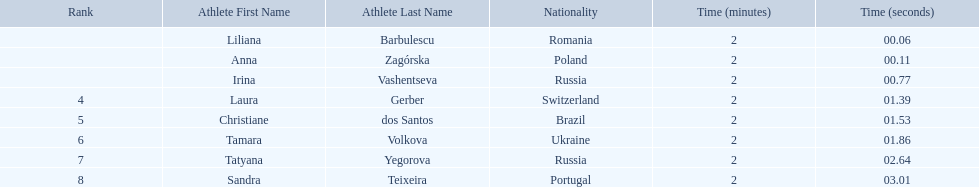What athletes are in the top five for the women's 800 metres? Liliana Barbulescu, Anna Zagórska, Irina Vashentseva, Laura Gerber, Christiane dos Santos. Which athletes are in the top 3? Liliana Barbulescu, Anna Zagórska, Irina Vashentseva. Who is the second place runner in the women's 800 metres? Anna Zagórska. What is the second place runner's time? 2:00.11. 